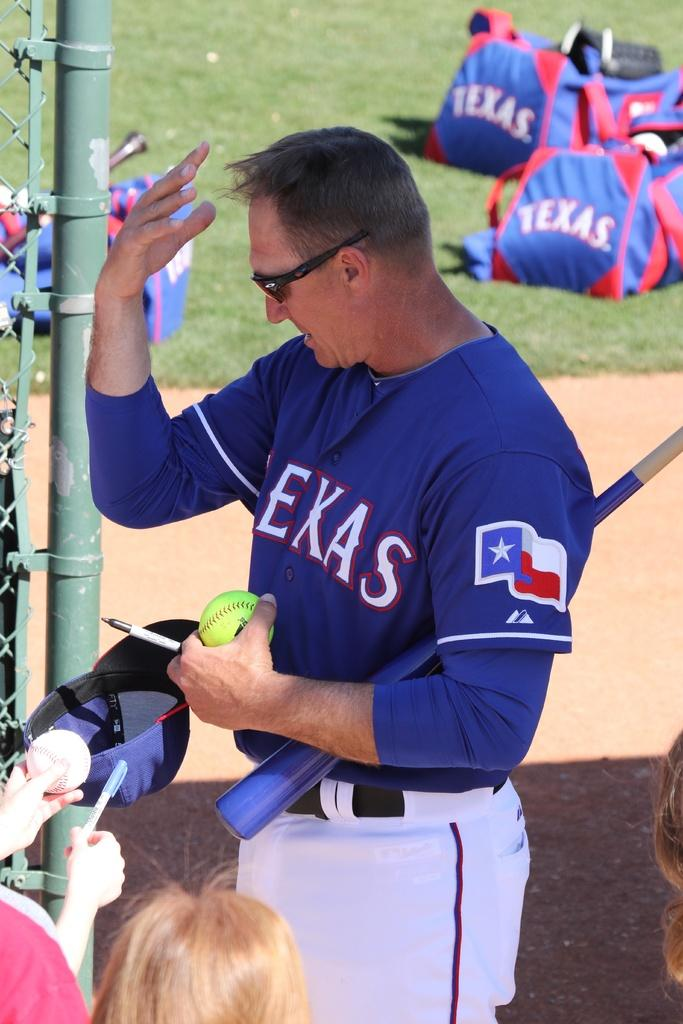Provide a one-sentence caption for the provided image. A ball player in a blue Texas shirt signs autographs for fans. 